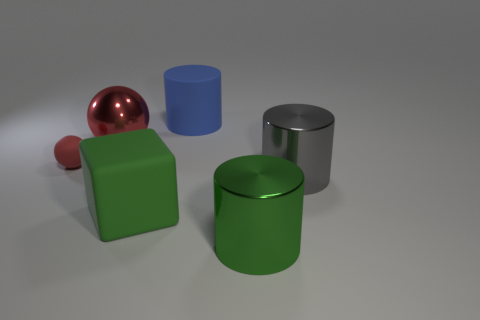Subtract all big blue rubber cylinders. How many cylinders are left? 2 Add 1 big red matte blocks. How many objects exist? 7 Subtract all blocks. How many objects are left? 5 Subtract all purple cylinders. Subtract all green cubes. How many cylinders are left? 3 Add 5 small rubber balls. How many small rubber balls are left? 6 Add 1 big red cylinders. How many big red cylinders exist? 1 Subtract 1 gray cylinders. How many objects are left? 5 Subtract all large blue rubber cylinders. Subtract all small brown shiny blocks. How many objects are left? 5 